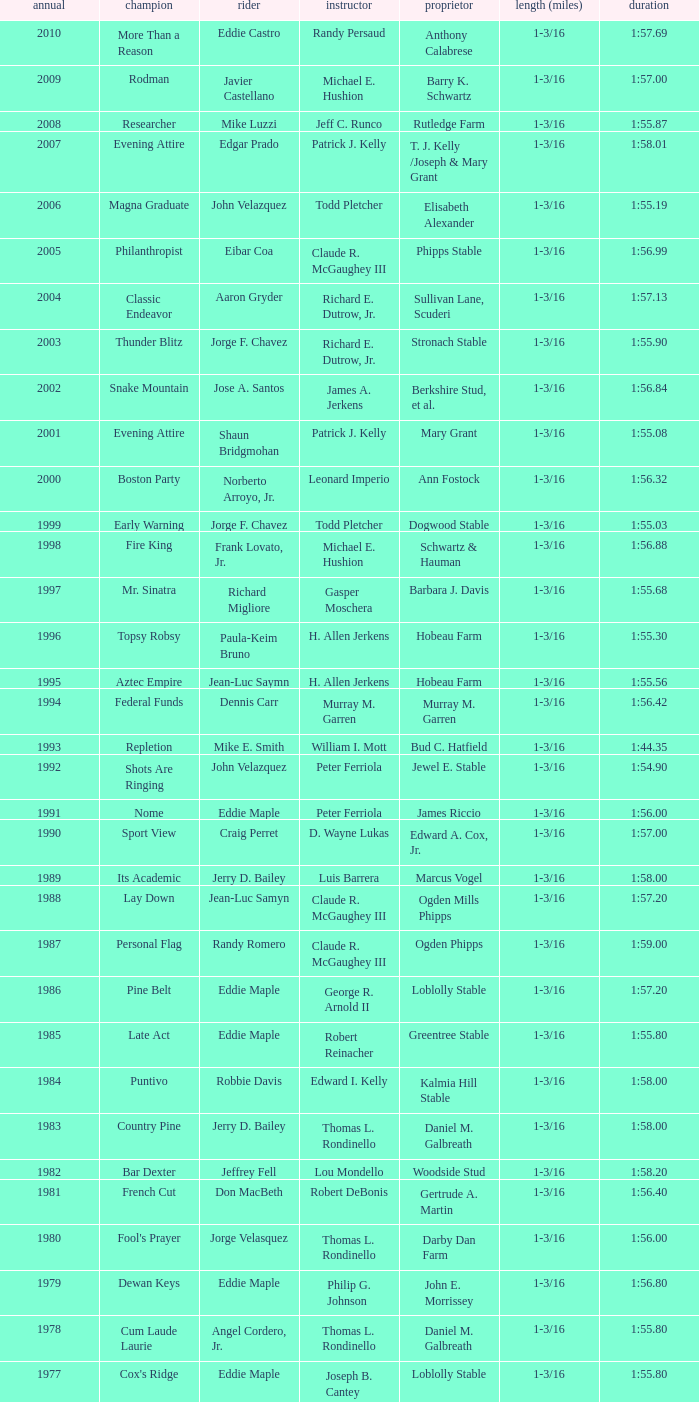What horse won with a trainer of "no race"? No Race, No Race, No Race, No Race. 